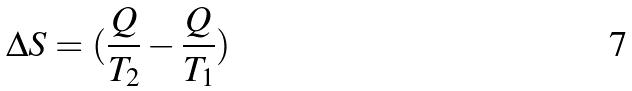Convert formula to latex. <formula><loc_0><loc_0><loc_500><loc_500>\Delta S = ( \frac { Q } { T _ { 2 } } - \frac { Q } { T _ { 1 } } )</formula> 